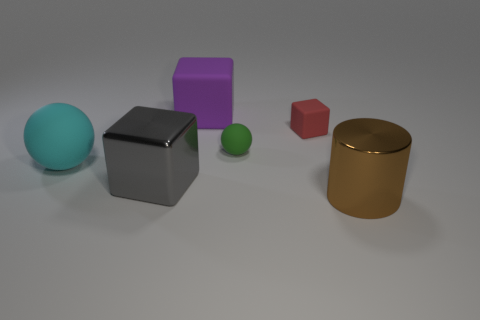There is a object that is on the left side of the shiny thing that is behind the thing that is in front of the big gray metal object; how big is it?
Offer a terse response. Large. What shape is the large matte thing to the left of the large rubber block?
Provide a succinct answer. Sphere. Is the number of blue rubber things greater than the number of small red blocks?
Provide a short and direct response. No. What shape is the big shiny object on the left side of the large metal object that is right of the purple cube?
Ensure brevity in your answer.  Cube. Do the big rubber cube and the large sphere have the same color?
Make the answer very short. No. Are there more brown shiny objects that are behind the big purple rubber thing than big cylinders?
Your answer should be very brief. No. There is a metallic object right of the red rubber block; how many big cyan things are on the right side of it?
Make the answer very short. 0. Do the big object that is left of the large gray metal thing and the big block behind the large gray object have the same material?
Offer a terse response. Yes. How many big brown objects are the same shape as the large gray object?
Your response must be concise. 0. Is the material of the big cylinder the same as the large block that is left of the large matte block?
Keep it short and to the point. Yes. 